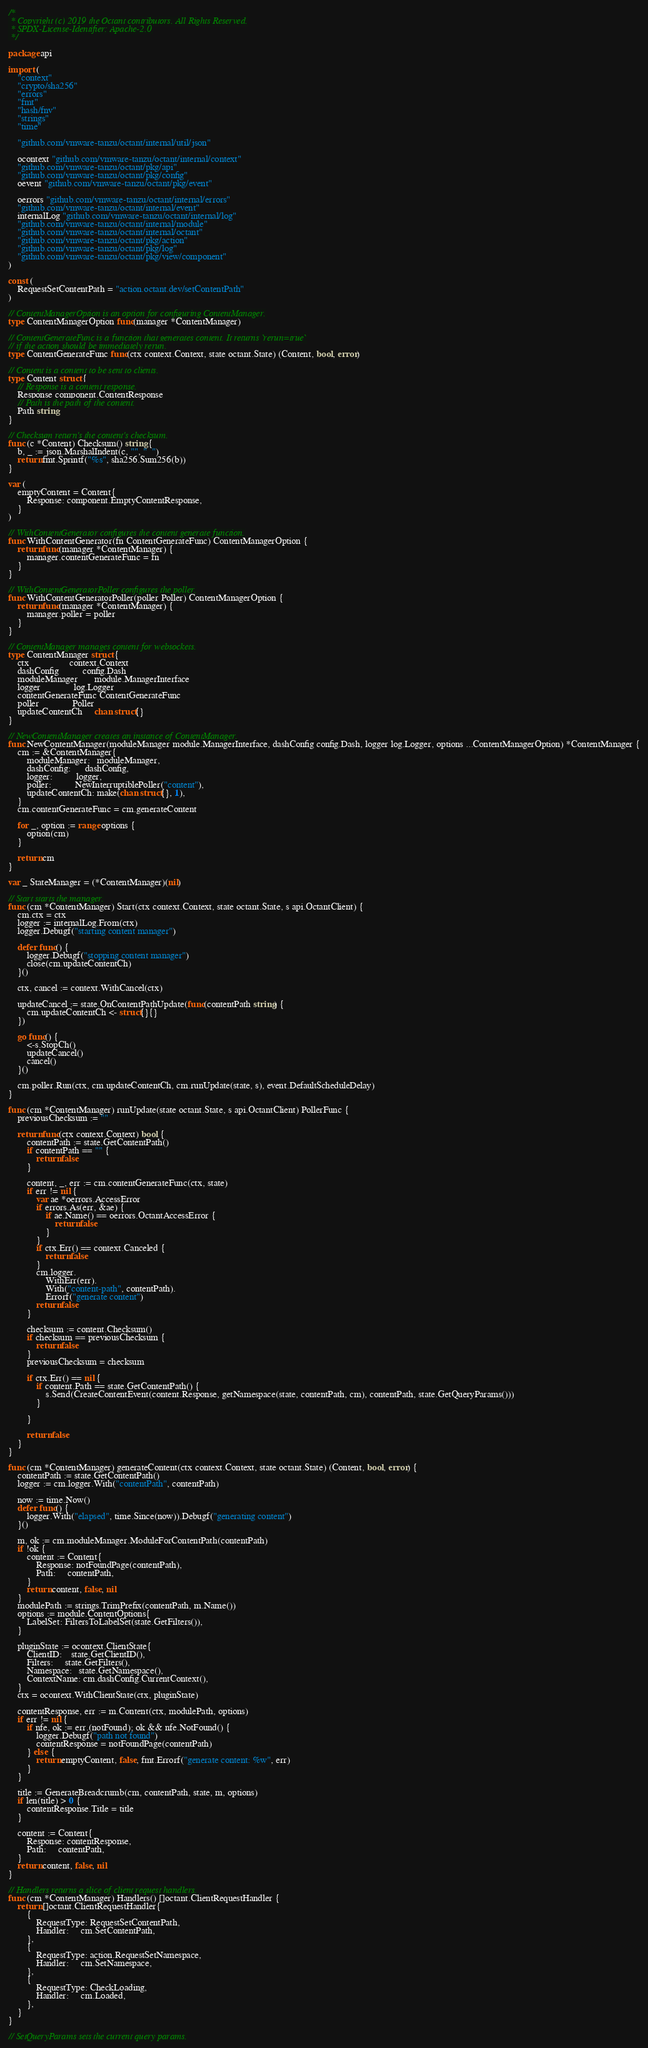Convert code to text. <code><loc_0><loc_0><loc_500><loc_500><_Go_>/*
 * Copyright (c) 2019 the Octant contributors. All Rights Reserved.
 * SPDX-License-Identifier: Apache-2.0
 */

package api

import (
	"context"
	"crypto/sha256"
	"errors"
	"fmt"
	"hash/fnv"
	"strings"
	"time"

	"github.com/vmware-tanzu/octant/internal/util/json"

	ocontext "github.com/vmware-tanzu/octant/internal/context"
	"github.com/vmware-tanzu/octant/pkg/api"
	"github.com/vmware-tanzu/octant/pkg/config"
	oevent "github.com/vmware-tanzu/octant/pkg/event"

	oerrors "github.com/vmware-tanzu/octant/internal/errors"
	"github.com/vmware-tanzu/octant/internal/event"
	internalLog "github.com/vmware-tanzu/octant/internal/log"
	"github.com/vmware-tanzu/octant/internal/module"
	"github.com/vmware-tanzu/octant/internal/octant"
	"github.com/vmware-tanzu/octant/pkg/action"
	"github.com/vmware-tanzu/octant/pkg/log"
	"github.com/vmware-tanzu/octant/pkg/view/component"
)

const (
	RequestSetContentPath = "action.octant.dev/setContentPath"
)

// ContentManagerOption is an option for configuring ContentManager.
type ContentManagerOption func(manager *ContentManager)

// ContentGenerateFunc is a function that generates content. It returns `rerun=true`
// if the action should be immediately rerun.
type ContentGenerateFunc func(ctx context.Context, state octant.State) (Content, bool, error)

// Content is a content to be sent to clients.
type Content struct {
	// Response is a content response.
	Response component.ContentResponse
	// Path is the path of the content.
	Path string
}

// Checksum return's the content's checksum.
func (c *Content) Checksum() string {
	b, _ := json.MarshalIndent(c, "", "  ")
	return fmt.Sprintf("%s", sha256.Sum256(b))
}

var (
	emptyContent = Content{
		Response: component.EmptyContentResponse,
	}
)

// WithContentGenerator configures the content generate function.
func WithContentGenerator(fn ContentGenerateFunc) ContentManagerOption {
	return func(manager *ContentManager) {
		manager.contentGenerateFunc = fn
	}
}

// WithContentGeneratorPoller configures the poller.
func WithContentGeneratorPoller(poller Poller) ContentManagerOption {
	return func(manager *ContentManager) {
		manager.poller = poller
	}
}

// ContentManager manages content for websockets.
type ContentManager struct {
	ctx                 context.Context
	dashConfig          config.Dash
	moduleManager       module.ManagerInterface
	logger              log.Logger
	contentGenerateFunc ContentGenerateFunc
	poller              Poller
	updateContentCh     chan struct{}
}

// NewContentManager creates an instance of ContentManager.
func NewContentManager(moduleManager module.ManagerInterface, dashConfig config.Dash, logger log.Logger, options ...ContentManagerOption) *ContentManager {
	cm := &ContentManager{
		moduleManager:   moduleManager,
		dashConfig:      dashConfig,
		logger:          logger,
		poller:          NewInterruptiblePoller("content"),
		updateContentCh: make(chan struct{}, 1),
	}
	cm.contentGenerateFunc = cm.generateContent

	for _, option := range options {
		option(cm)
	}

	return cm
}

var _ StateManager = (*ContentManager)(nil)

// Start starts the manager.
func (cm *ContentManager) Start(ctx context.Context, state octant.State, s api.OctantClient) {
	cm.ctx = ctx
	logger := internalLog.From(ctx)
	logger.Debugf("starting content manager")

	defer func() {
		logger.Debugf("stopping content manager")
		close(cm.updateContentCh)
	}()

	ctx, cancel := context.WithCancel(ctx)

	updateCancel := state.OnContentPathUpdate(func(contentPath string) {
		cm.updateContentCh <- struct{}{}
	})

	go func() {
		<-s.StopCh()
		updateCancel()
		cancel()
	}()

	cm.poller.Run(ctx, cm.updateContentCh, cm.runUpdate(state, s), event.DefaultScheduleDelay)
}

func (cm *ContentManager) runUpdate(state octant.State, s api.OctantClient) PollerFunc {
	previousChecksum := ""

	return func(ctx context.Context) bool {
		contentPath := state.GetContentPath()
		if contentPath == "" {
			return false
		}

		content, _, err := cm.contentGenerateFunc(ctx, state)
		if err != nil {
			var ae *oerrors.AccessError
			if errors.As(err, &ae) {
				if ae.Name() == oerrors.OctantAccessError {
					return false
				}
			}
			if ctx.Err() == context.Canceled {
				return false
			}
			cm.logger.
				WithErr(err).
				With("content-path", contentPath).
				Errorf("generate content")
			return false
		}

		checksum := content.Checksum()
		if checksum == previousChecksum {
			return false
		}
		previousChecksum = checksum

		if ctx.Err() == nil {
			if content.Path == state.GetContentPath() {
				s.Send(CreateContentEvent(content.Response, getNamespace(state, contentPath, cm), contentPath, state.GetQueryParams()))
			}

		}

		return false
	}
}

func (cm *ContentManager) generateContent(ctx context.Context, state octant.State) (Content, bool, error) {
	contentPath := state.GetContentPath()
	logger := cm.logger.With("contentPath", contentPath)

	now := time.Now()
	defer func() {
		logger.With("elapsed", time.Since(now)).Debugf("generating content")
	}()

	m, ok := cm.moduleManager.ModuleForContentPath(contentPath)
	if !ok {
		content := Content{
			Response: notFoundPage(contentPath),
			Path:     contentPath,
		}
		return content, false, nil
	}
	modulePath := strings.TrimPrefix(contentPath, m.Name())
	options := module.ContentOptions{
		LabelSet: FiltersToLabelSet(state.GetFilters()),
	}

	pluginState := ocontext.ClientState{
		ClientID:    state.GetClientID(),
		Filters:     state.GetFilters(),
		Namespace:   state.GetNamespace(),
		ContextName: cm.dashConfig.CurrentContext(),
	}
	ctx = ocontext.WithClientState(ctx, pluginState)

	contentResponse, err := m.Content(ctx, modulePath, options)
	if err != nil {
		if nfe, ok := err.(notFound); ok && nfe.NotFound() {
			logger.Debugf("path not found")
			contentResponse = notFoundPage(contentPath)
		} else {
			return emptyContent, false, fmt.Errorf("generate content: %w", err)
		}
	}

	title := GenerateBreadcrumb(cm, contentPath, state, m, options)
	if len(title) > 0 {
		contentResponse.Title = title
	}

	content := Content{
		Response: contentResponse,
		Path:     contentPath,
	}
	return content, false, nil
}

// Handlers returns a slice of client request handlers.
func (cm *ContentManager) Handlers() []octant.ClientRequestHandler {
	return []octant.ClientRequestHandler{
		{
			RequestType: RequestSetContentPath,
			Handler:     cm.SetContentPath,
		},
		{
			RequestType: action.RequestSetNamespace,
			Handler:     cm.SetNamespace,
		},
		{
			RequestType: CheckLoading,
			Handler:     cm.Loaded,
		},
	}
}

// SetQueryParams sets the current query params.</code> 